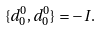Convert formula to latex. <formula><loc_0><loc_0><loc_500><loc_500>\{ d _ { 0 } ^ { 0 } , d _ { 0 } ^ { 0 } \} = - I .</formula> 